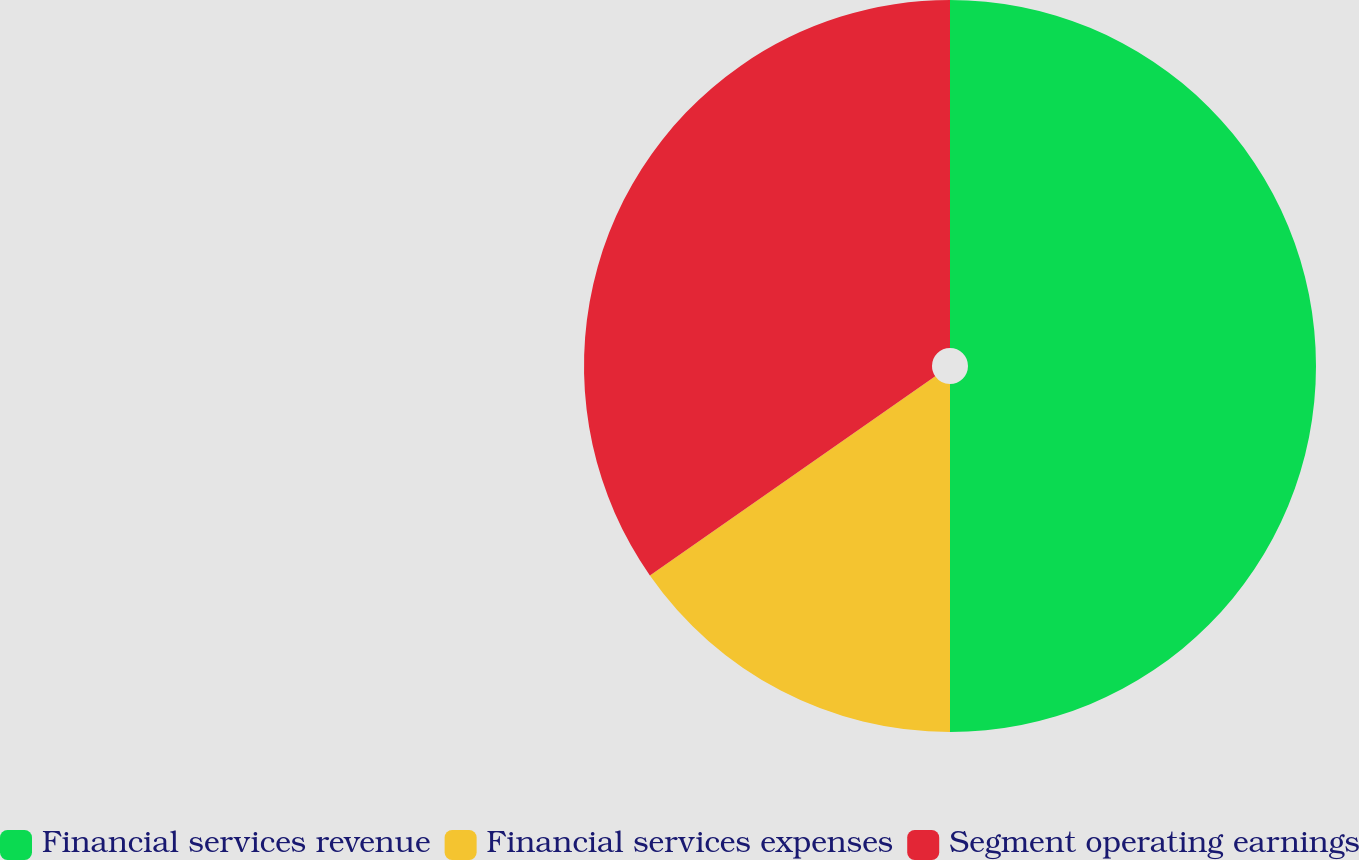Convert chart to OTSL. <chart><loc_0><loc_0><loc_500><loc_500><pie_chart><fcel>Financial services revenue<fcel>Financial services expenses<fcel>Segment operating earnings<nl><fcel>50.0%<fcel>15.3%<fcel>34.7%<nl></chart> 